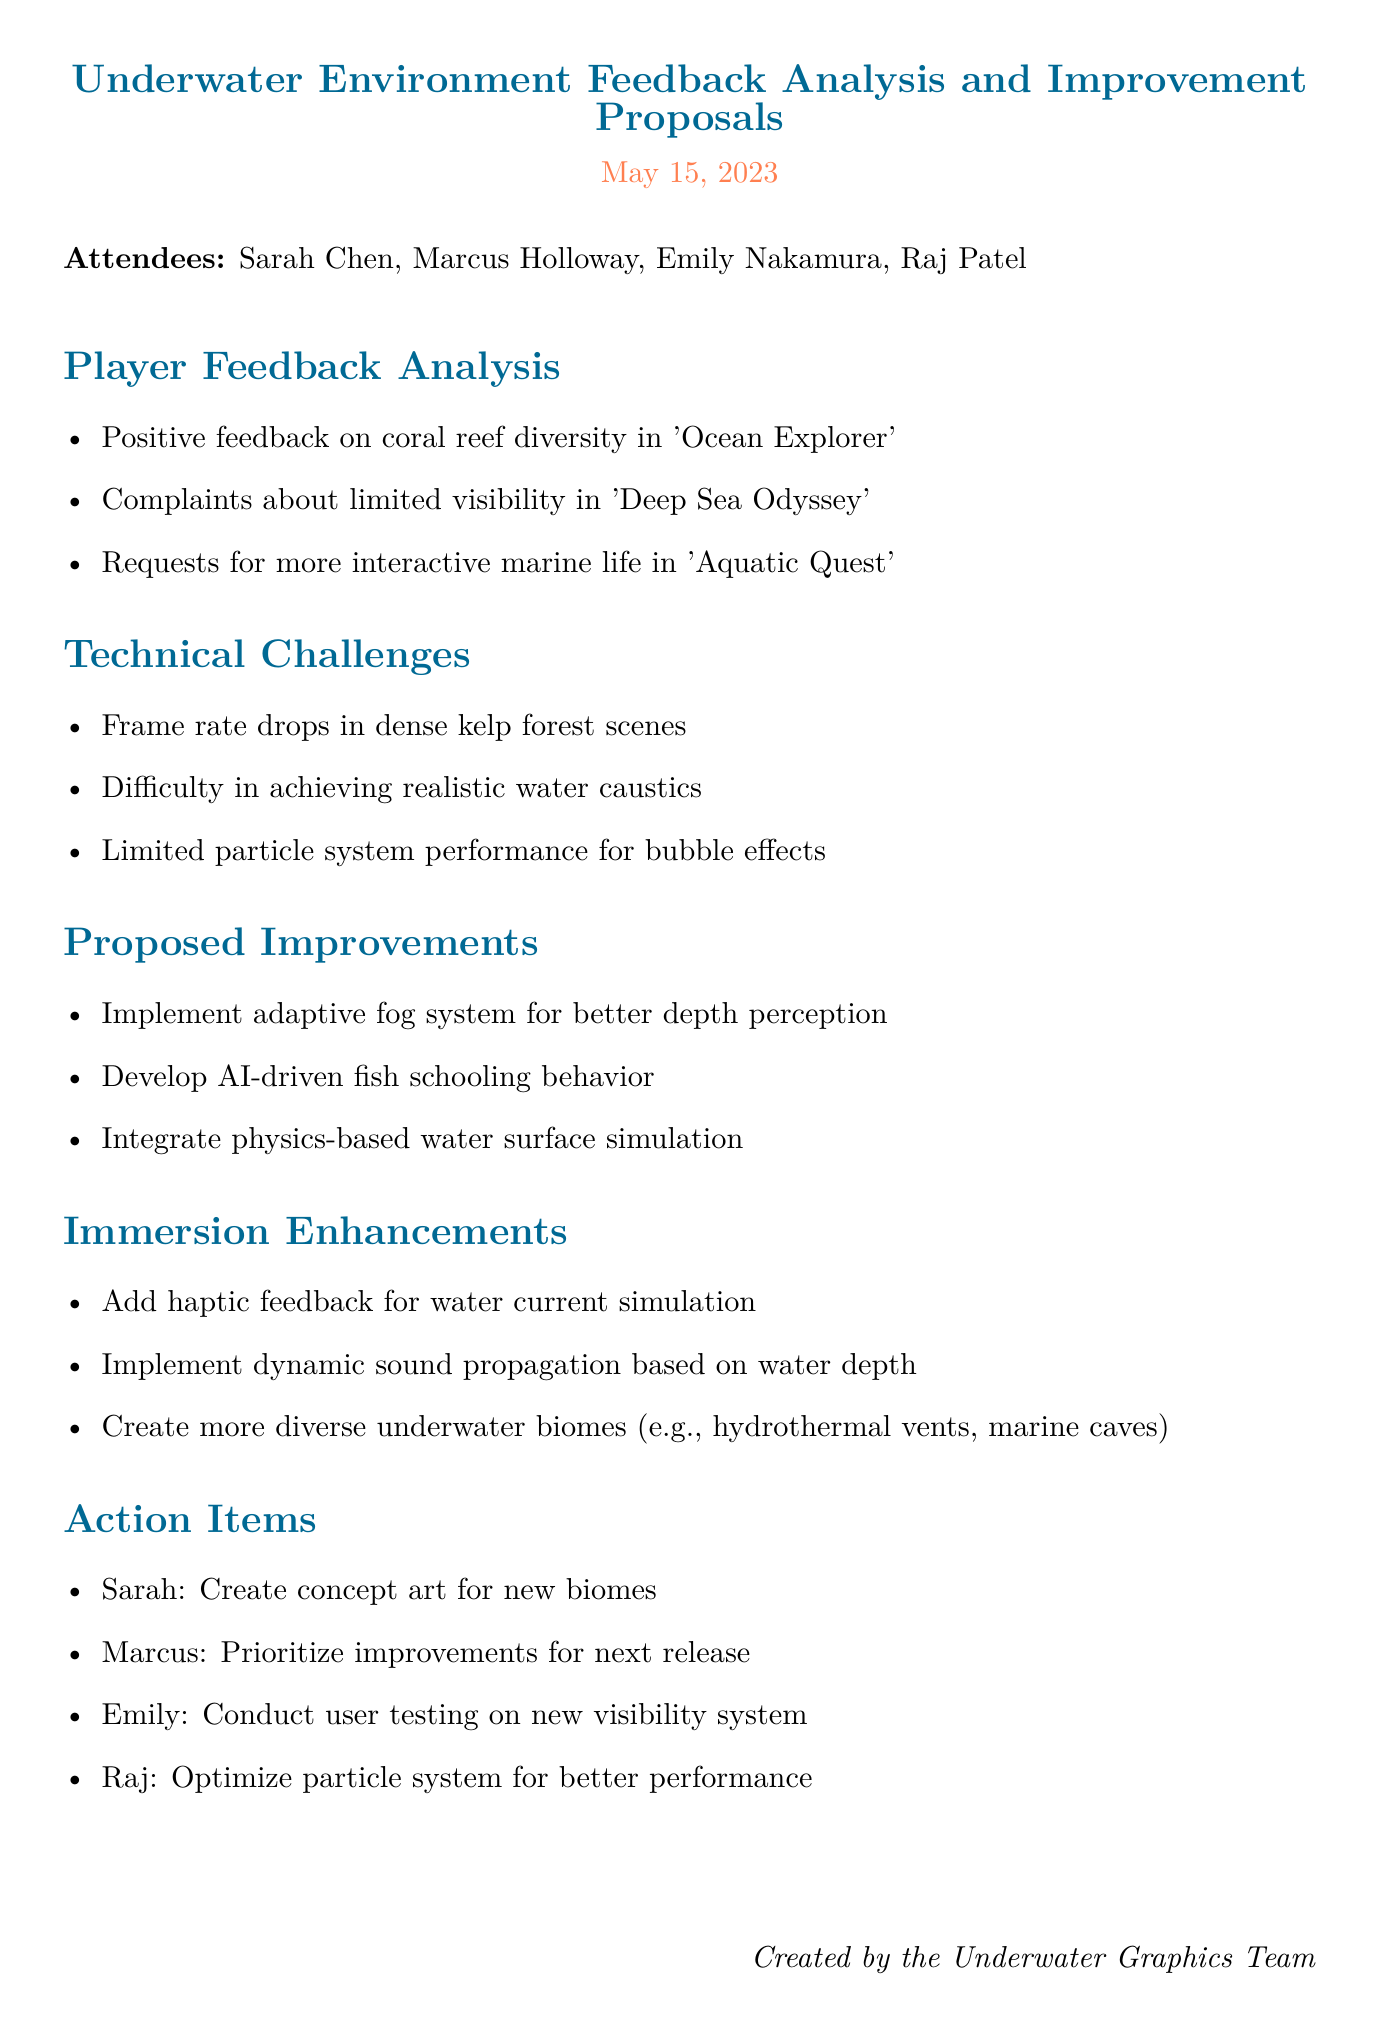What is the date of the meeting? The date of the meeting is stated at the top of the document.
Answer: May 15, 2023 Who is the user experience researcher in the meeting? The document lists the attendees, including the user experience researcher.
Answer: Emily Nakamura What positive feedback was mentioned in the player feedback analysis? The feedback analyzed in the document highlights specific aspects of player experience regarding underwater environments.
Answer: Coral reef diversity in 'Ocean Explorer' What technical challenge involves realism? The technical challenges discussed include specific issues faced in creating realistic underwater effects.
Answer: Realistic water caustics Which action item is assigned to Sarah? The action items outline responsibilities assigned to each team member based on the discussions in the document.
Answer: Create concept art for new biomes What immersion enhancement involves feedback? The immersion enhancements section specifies methods to increase player engagement through technology and feedback.
Answer: Haptic feedback for water current simulation 